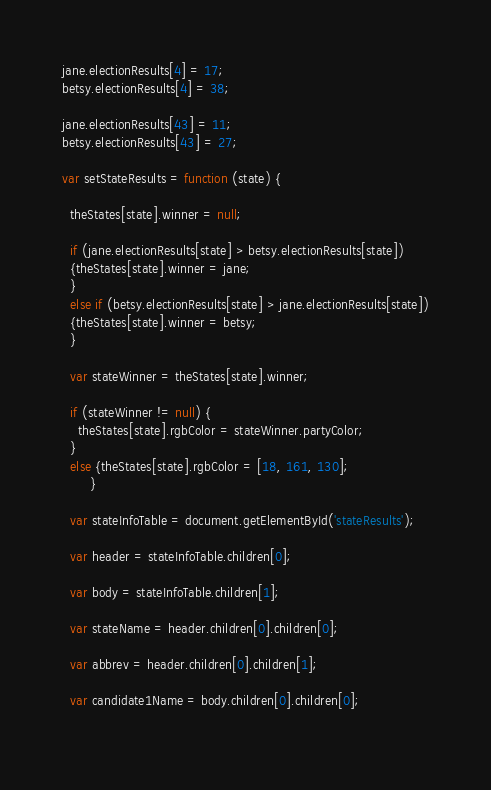Convert code to text. <code><loc_0><loc_0><loc_500><loc_500><_JavaScript_>
jane.electionResults[4] = 17;
betsy.electionResults[4] = 38;

jane.electionResults[43] = 11;
betsy.electionResults[43] = 27;

var setStateResults = function (state) {
  
  theStates[state].winner = null;
  
  if (jane.electionResults[state] > betsy.electionResults[state]) 
  {theStates[state].winner = jane;
  } 
  else if (betsy.electionResults[state] > jane.electionResults[state])
  {theStates[state].winner = betsy;
  } 
  
  var stateWinner = theStates[state].winner;
  
  if (stateWinner != null) {
    theStates[state].rgbColor = stateWinner.partyColor;
  } 
  else {theStates[state].rgbColor = [18, 161, 130];
       }
  
  var stateInfoTable = document.getElementById('stateResults');
  
  var header = stateInfoTable.children[0];
  
  var body = stateInfoTable.children[1];
  
  var stateName = header.children[0].children[0];
  
  var abbrev = header.children[0].children[1];
  
  var candidate1Name = body.children[0].children[0];
  </code> 